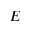Convert formula to latex. <formula><loc_0><loc_0><loc_500><loc_500>E</formula> 